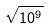Convert formula to latex. <formula><loc_0><loc_0><loc_500><loc_500>\sqrt { 1 0 ^ { 9 } }</formula> 